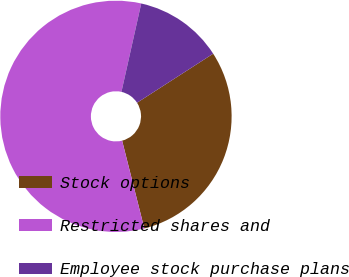Convert chart to OTSL. <chart><loc_0><loc_0><loc_500><loc_500><pie_chart><fcel>Stock options<fcel>Restricted shares and<fcel>Employee stock purchase plans<nl><fcel>30.17%<fcel>57.45%<fcel>12.38%<nl></chart> 